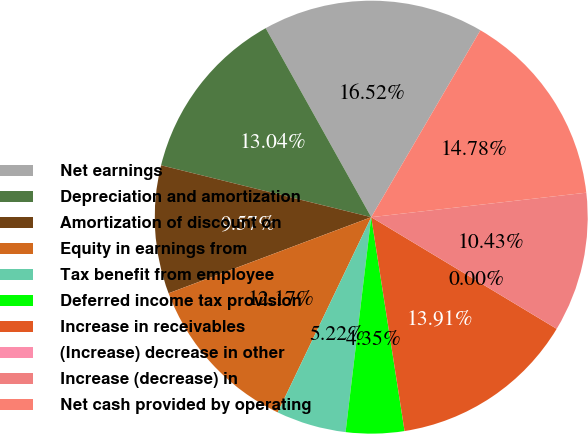Convert chart to OTSL. <chart><loc_0><loc_0><loc_500><loc_500><pie_chart><fcel>Net earnings<fcel>Depreciation and amortization<fcel>Amortization of discount on<fcel>Equity in earnings from<fcel>Tax benefit from employee<fcel>Deferred income tax provision<fcel>Increase in receivables<fcel>(Increase) decrease in other<fcel>Increase (decrease) in<fcel>Net cash provided by operating<nl><fcel>16.52%<fcel>13.04%<fcel>9.57%<fcel>12.17%<fcel>5.22%<fcel>4.35%<fcel>13.91%<fcel>0.0%<fcel>10.43%<fcel>14.78%<nl></chart> 